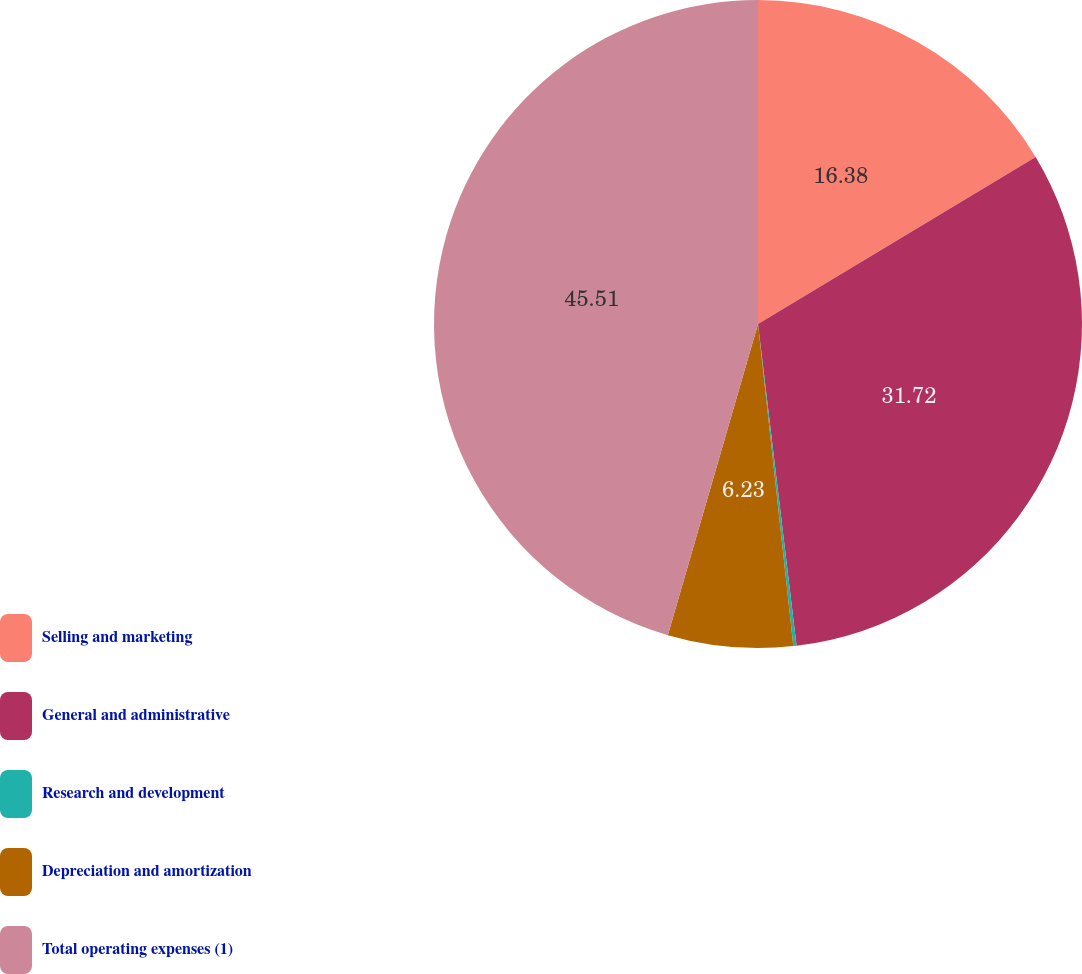Convert chart to OTSL. <chart><loc_0><loc_0><loc_500><loc_500><pie_chart><fcel>Selling and marketing<fcel>General and administrative<fcel>Research and development<fcel>Depreciation and amortization<fcel>Total operating expenses (1)<nl><fcel>16.38%<fcel>31.72%<fcel>0.16%<fcel>6.23%<fcel>45.51%<nl></chart> 